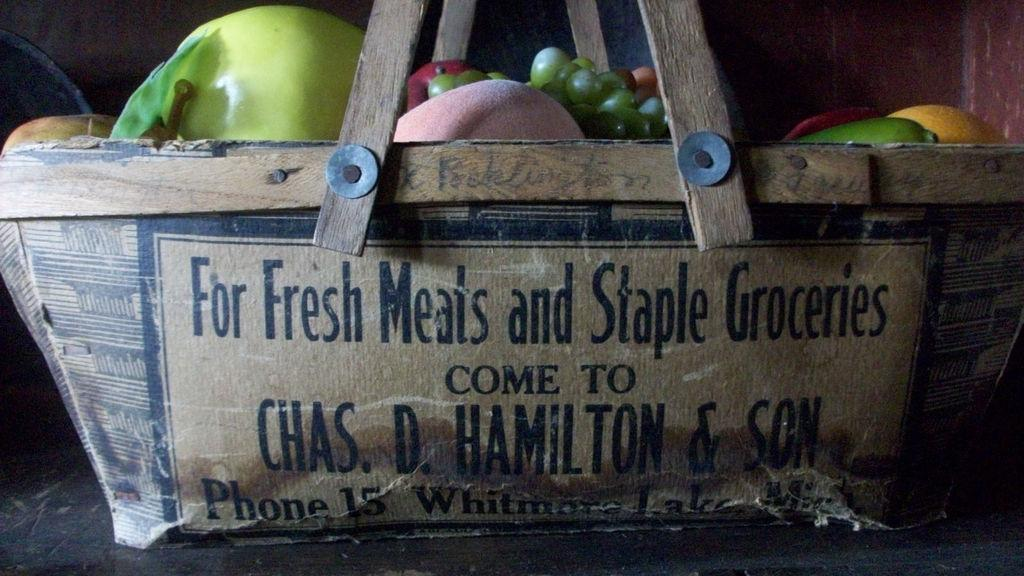What is on the platform in the image? There is a basket on the platform in the image. What is inside the basket? The basket contains fruits. Can you describe the background of the image? There is an object and a wall in the background of the image. How many dolls are sitting on the quilt in the image? There are no dolls or quilts present in the image. 